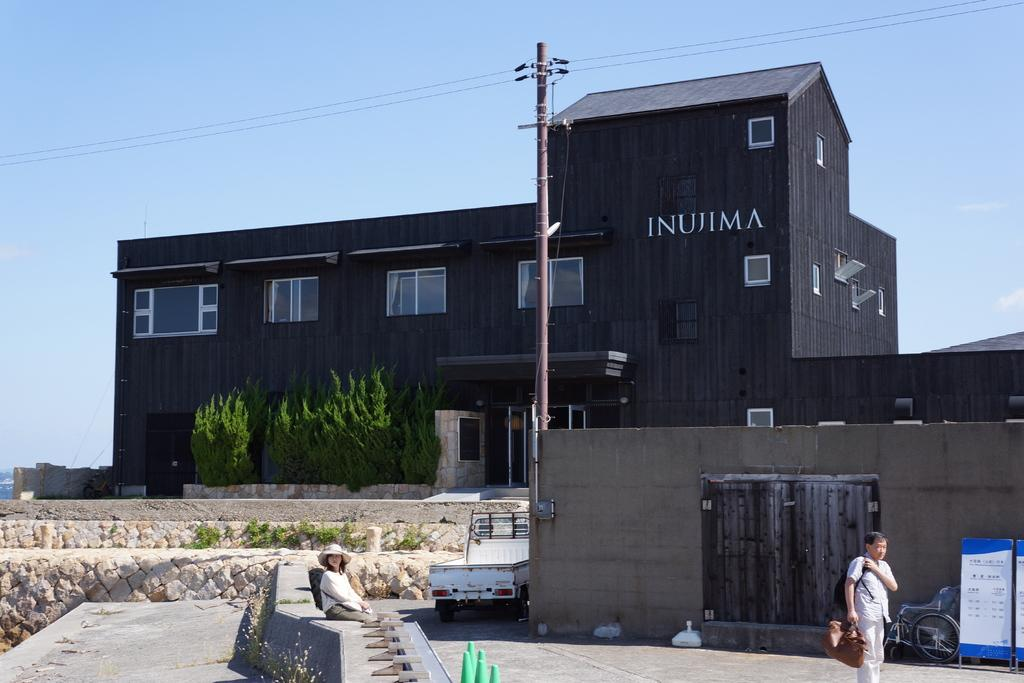What type of structure is visible in the image? There is a building with windows in the image. What is the person holding in the image? The person is standing and holding a bag in the image. What is the woman doing in the image? The woman is sitting in the image. What can be seen attached to the pole in the image? There are cables attached to the pole in the image. What is visible in the background of the image? The sky is visible in the image, and there are trees present as well. Can you see any wounds on the person holding the bag in the image? There is no mention of any wounds in the image, and therefore it cannot be determined if any are present. What type of credit is the woman using to sit in the image? There is no reference to credit in the image, and the woman is simply sitting. 